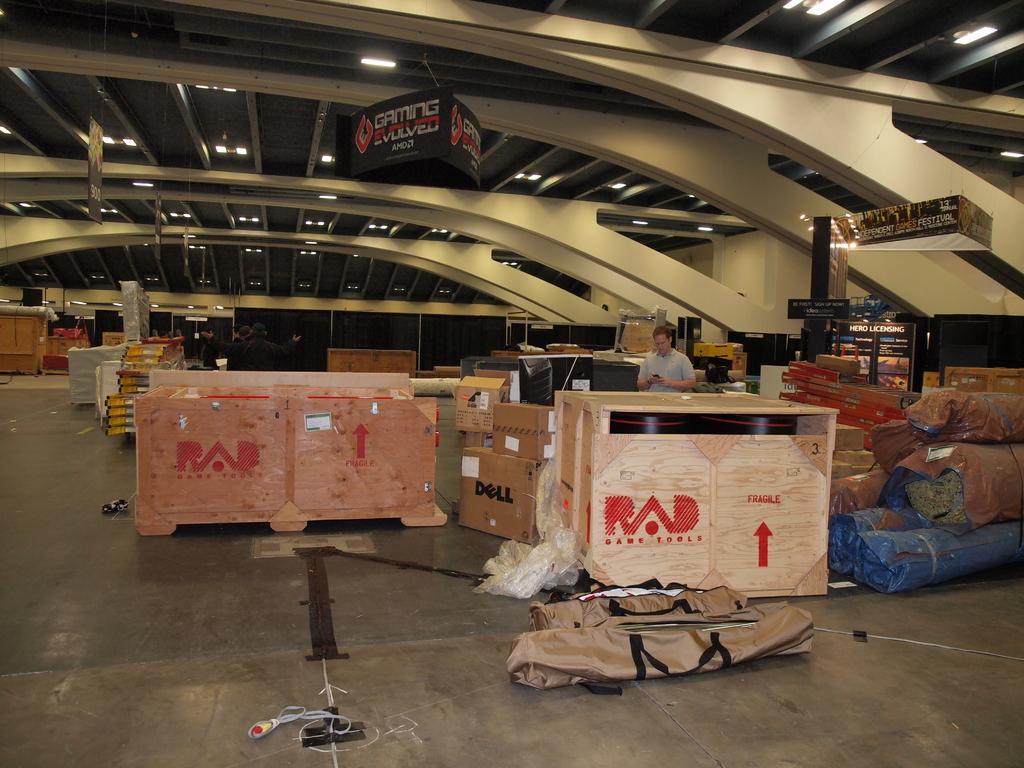In one or two sentences, can you explain what this image depicts? This is an inside view. Here I can see many card boxes and bags on the floor. There is a man standing holding a mobile in the hand and looking into the mobile. On the right side there is a pillar to which a board is attached. On the board, I can see some text. In the background there are few people standing and also I can see tables, boxes and many other objects on the floor. In the background there is a wall. At the top I can see few lights to the roof. 